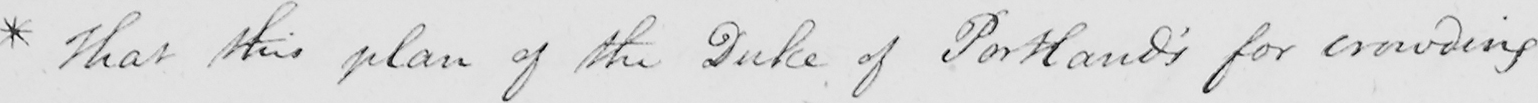What is written in this line of handwriting? * that this plan of the Duke of Portland ' s for crowding 